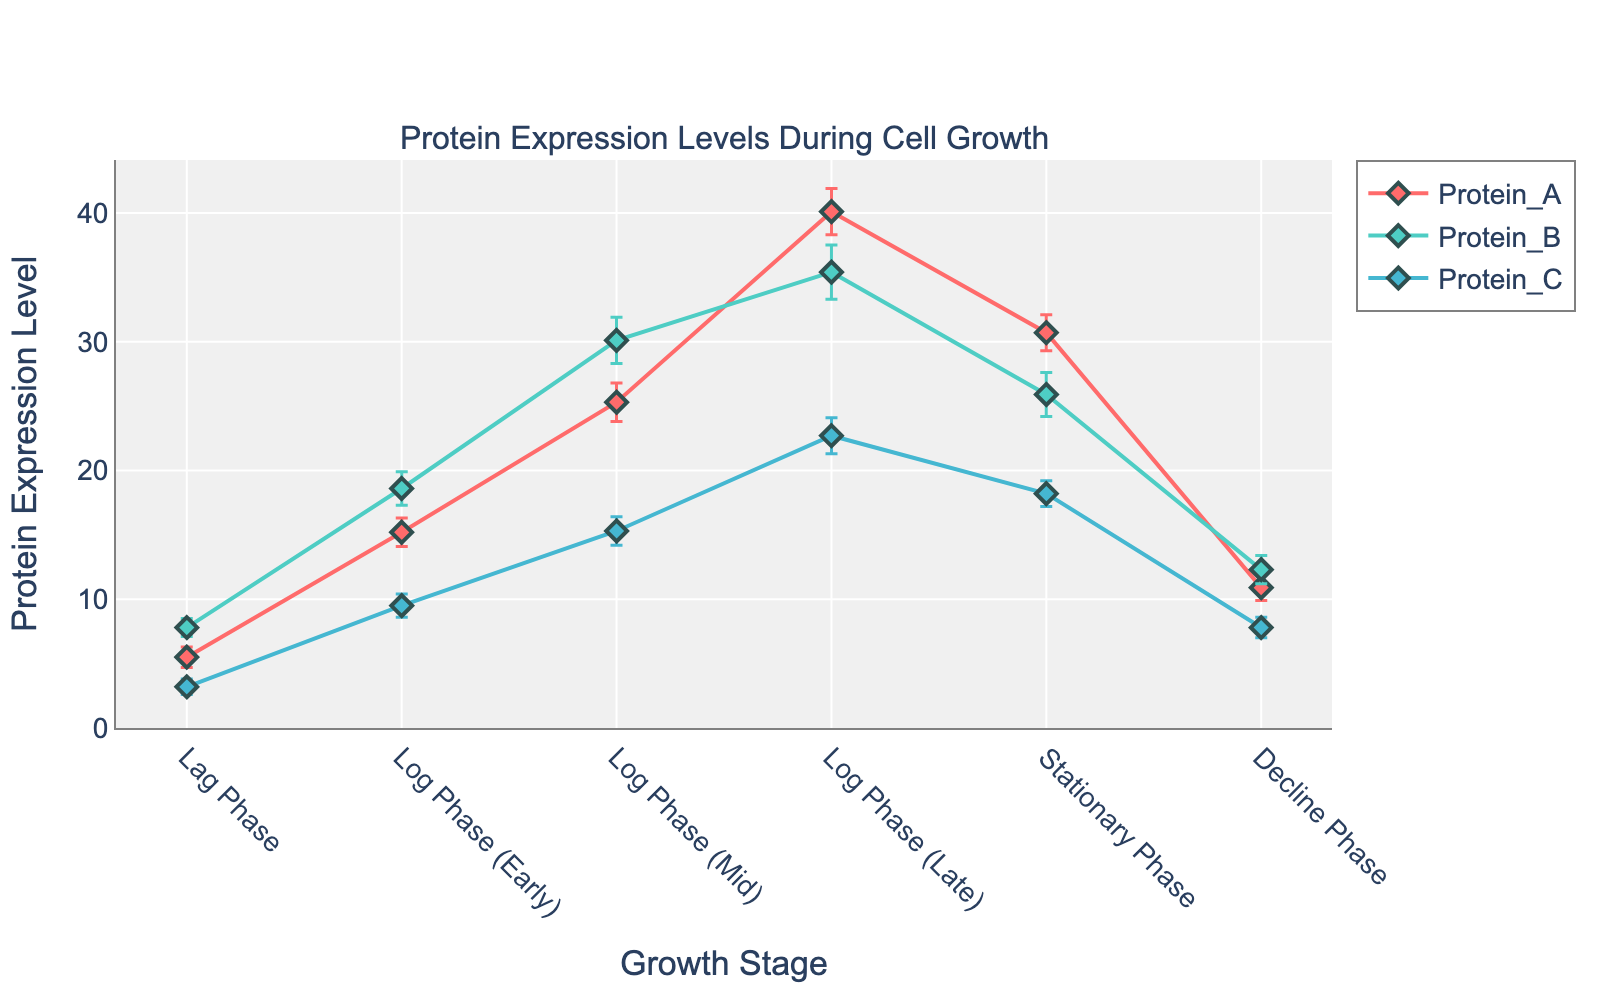What is the title of the plot? The title of the plot is located at the top and it provides an overview of what the plot represents. By looking at the figure, you can see the title displayed prominently.
Answer: Protein Expression Levels During Cell Growth Which stage has the highest expression level for Protein B? To find this, look at the line corresponding to Protein B and identify the peak point. Examine the y-values along the x-axis stages to see where the highest value occurs.
Answer: Log Phase (Mid) At which stage do Protein A and Protein B have the closest expression levels? To determine this, examine the lines for Protein A and Protein B and look for the stage where their y-values are closest to each other. Compare their expression levels at each growth stage.
Answer: Decline Phase What is the range of Protein C expression levels across all stages? Find the lowest and the highest expression levels of Protein C from the y-axis values corresponding to each stage. Subtract the lowest value from the highest value to get the range.
Answer: 22.7 - 3.2 = 19.5 Which protein has the largest standard deviation in the Log Phase (Late)? Look at the error bars (standard deviations) for each protein in the Log Phase (Late). The protein with the longest error bar length has the largest standard deviation.
Answer: Protein B How much higher is the expression level of Protein A in the Log Phase (Mid) compared to the Stationary Phase? Find the expression levels of Protein A in both the Log Phase (Mid) and the Stationary Phase. Subtract the value in the Stationary Phase from that in the Log Phase (Mid).
Answer: 25.3 - 30.7 = -5.4 Which protein shows a decrease in expression level from the Log Phase (Late) to the Stationary Phase? Observe the trend lines for each protein from the Log Phase (Late) to the Stationary Phase. Identify the protein whose y-value declines.
Answer: Protein A and Protein B What is the mean expression level of Protein C during the Lag Phase and Log Phase (Early)? Add the expression levels of Protein C in the Lag Phase and Log Phase (Early). Divide by 2 to find the mean.
Answer: (3.2 + 9.5) / 2 = 6.35 